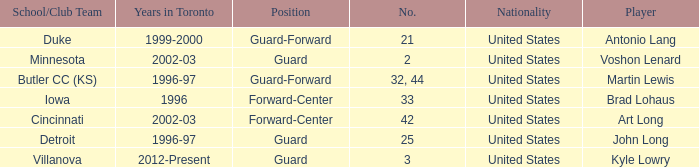What school did player number 21 play for? Duke. 